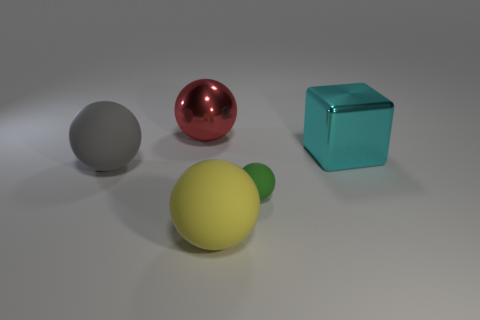Subtract all large gray matte balls. How many balls are left? 3 Add 4 big purple metallic cylinders. How many objects exist? 9 Subtract all yellow balls. How many balls are left? 3 Subtract all cubes. How many objects are left? 4 Subtract all cyan spheres. Subtract all red cubes. How many spheres are left? 4 Add 3 tiny red objects. How many tiny red objects exist? 3 Subtract 0 red cylinders. How many objects are left? 5 Subtract all large cyan blocks. Subtract all large matte objects. How many objects are left? 2 Add 1 blocks. How many blocks are left? 2 